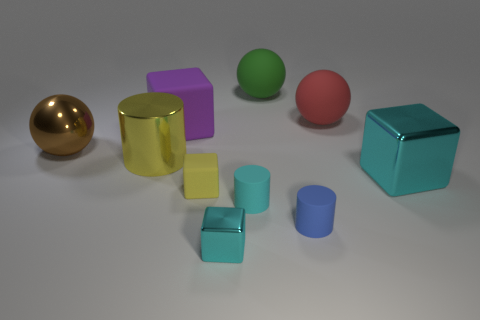What number of other things are there of the same shape as the big purple object?
Ensure brevity in your answer.  3. There is a big thing that is both left of the big red ball and to the right of the cyan rubber cylinder; what is its color?
Your answer should be compact. Green. There is a big block that is on the right side of the large purple thing; is its color the same as the tiny shiny object?
Ensure brevity in your answer.  Yes. How many cylinders are small rubber things or brown objects?
Offer a very short reply. 2. What is the shape of the big shiny object that is right of the cyan matte cylinder?
Offer a very short reply. Cube. What color is the large block that is to the left of the large block in front of the large object to the left of the shiny cylinder?
Your response must be concise. Purple. Do the small yellow cube and the large cylinder have the same material?
Offer a terse response. No. What number of green objects are metal things or tiny cubes?
Keep it short and to the point. 0. How many yellow cubes are on the left side of the large rubber cube?
Your answer should be compact. 0. Is the number of tiny blue cylinders greater than the number of cyan shiny blocks?
Offer a very short reply. No. 